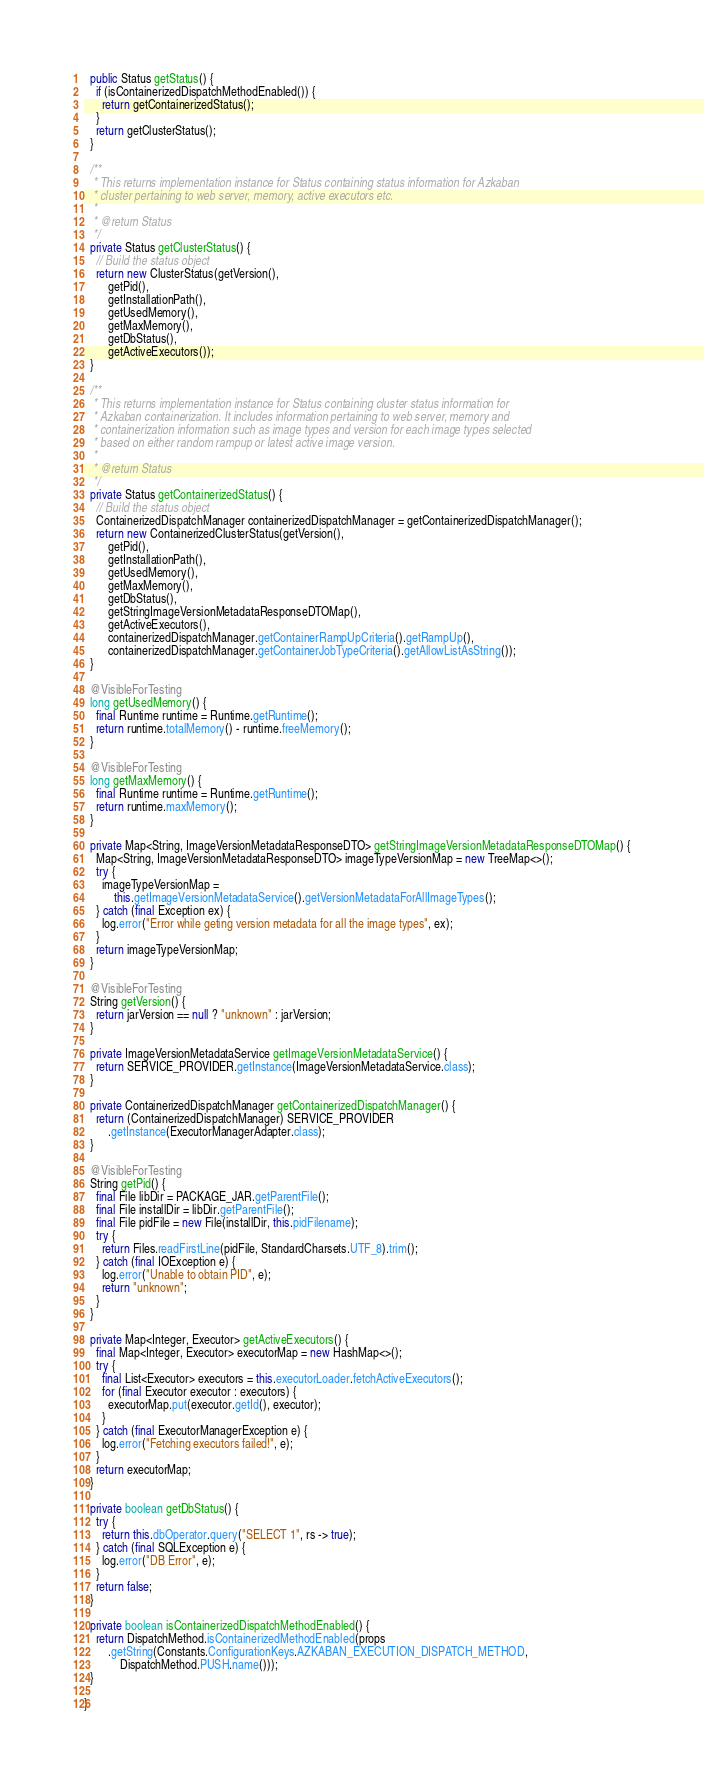<code> <loc_0><loc_0><loc_500><loc_500><_Java_>  public Status getStatus() {
    if (isContainerizedDispatchMethodEnabled()) {
      return getContainerizedStatus();
    }
    return getClusterStatus();
  }

  /**
   * This returns implementation instance for Status containing status information for Azkaban
   * cluster pertaining to web server, memory, active executors etc.
   *
   * @return Status
   */
  private Status getClusterStatus() {
    // Build the status object
    return new ClusterStatus(getVersion(),
        getPid(),
        getInstallationPath(),
        getUsedMemory(),
        getMaxMemory(),
        getDbStatus(),
        getActiveExecutors());
  }

  /**
   * This returns implementation instance for Status containing cluster status information for
   * Azkaban containerization. It includes information pertaining to web server, memory and
   * containerization information such as image types and version for each image types selected
   * based on either random rampup or latest active image version.
   *
   * @return Status
   */
  private Status getContainerizedStatus() {
    // Build the status object
    ContainerizedDispatchManager containerizedDispatchManager = getContainerizedDispatchManager();
    return new ContainerizedClusterStatus(getVersion(),
        getPid(),
        getInstallationPath(),
        getUsedMemory(),
        getMaxMemory(),
        getDbStatus(),
        getStringImageVersionMetadataResponseDTOMap(),
        getActiveExecutors(),
        containerizedDispatchManager.getContainerRampUpCriteria().getRampUp(),
        containerizedDispatchManager.getContainerJobTypeCriteria().getAllowListAsString());
  }

  @VisibleForTesting
  long getUsedMemory() {
    final Runtime runtime = Runtime.getRuntime();
    return runtime.totalMemory() - runtime.freeMemory();
  }

  @VisibleForTesting
  long getMaxMemory() {
    final Runtime runtime = Runtime.getRuntime();
    return runtime.maxMemory();
  }

  private Map<String, ImageVersionMetadataResponseDTO> getStringImageVersionMetadataResponseDTOMap() {
    Map<String, ImageVersionMetadataResponseDTO> imageTypeVersionMap = new TreeMap<>();
    try {
      imageTypeVersionMap =
          this.getImageVersionMetadataService().getVersionMetadataForAllImageTypes();
    } catch (final Exception ex) {
      log.error("Error while geting version metadata for all the image types", ex);
    }
    return imageTypeVersionMap;
  }

  @VisibleForTesting
  String getVersion() {
    return jarVersion == null ? "unknown" : jarVersion;
  }

  private ImageVersionMetadataService getImageVersionMetadataService() {
    return SERVICE_PROVIDER.getInstance(ImageVersionMetadataService.class);
  }

  private ContainerizedDispatchManager getContainerizedDispatchManager() {
    return (ContainerizedDispatchManager) SERVICE_PROVIDER
        .getInstance(ExecutorManagerAdapter.class);
  }

  @VisibleForTesting
  String getPid() {
    final File libDir = PACKAGE_JAR.getParentFile();
    final File installDir = libDir.getParentFile();
    final File pidFile = new File(installDir, this.pidFilename);
    try {
      return Files.readFirstLine(pidFile, StandardCharsets.UTF_8).trim();
    } catch (final IOException e) {
      log.error("Unable to obtain PID", e);
      return "unknown";
    }
  }

  private Map<Integer, Executor> getActiveExecutors() {
    final Map<Integer, Executor> executorMap = new HashMap<>();
    try {
      final List<Executor> executors = this.executorLoader.fetchActiveExecutors();
      for (final Executor executor : executors) {
        executorMap.put(executor.getId(), executor);
      }
    } catch (final ExecutorManagerException e) {
      log.error("Fetching executors failed!", e);
    }
    return executorMap;
  }

  private boolean getDbStatus() {
    try {
      return this.dbOperator.query("SELECT 1", rs -> true);
    } catch (final SQLException e) {
      log.error("DB Error", e);
    }
    return false;
  }

  private boolean isContainerizedDispatchMethodEnabled() {
    return DispatchMethod.isContainerizedMethodEnabled(props
        .getString(Constants.ConfigurationKeys.AZKABAN_EXECUTION_DISPATCH_METHOD,
            DispatchMethod.PUSH.name()));
  }

}
</code> 